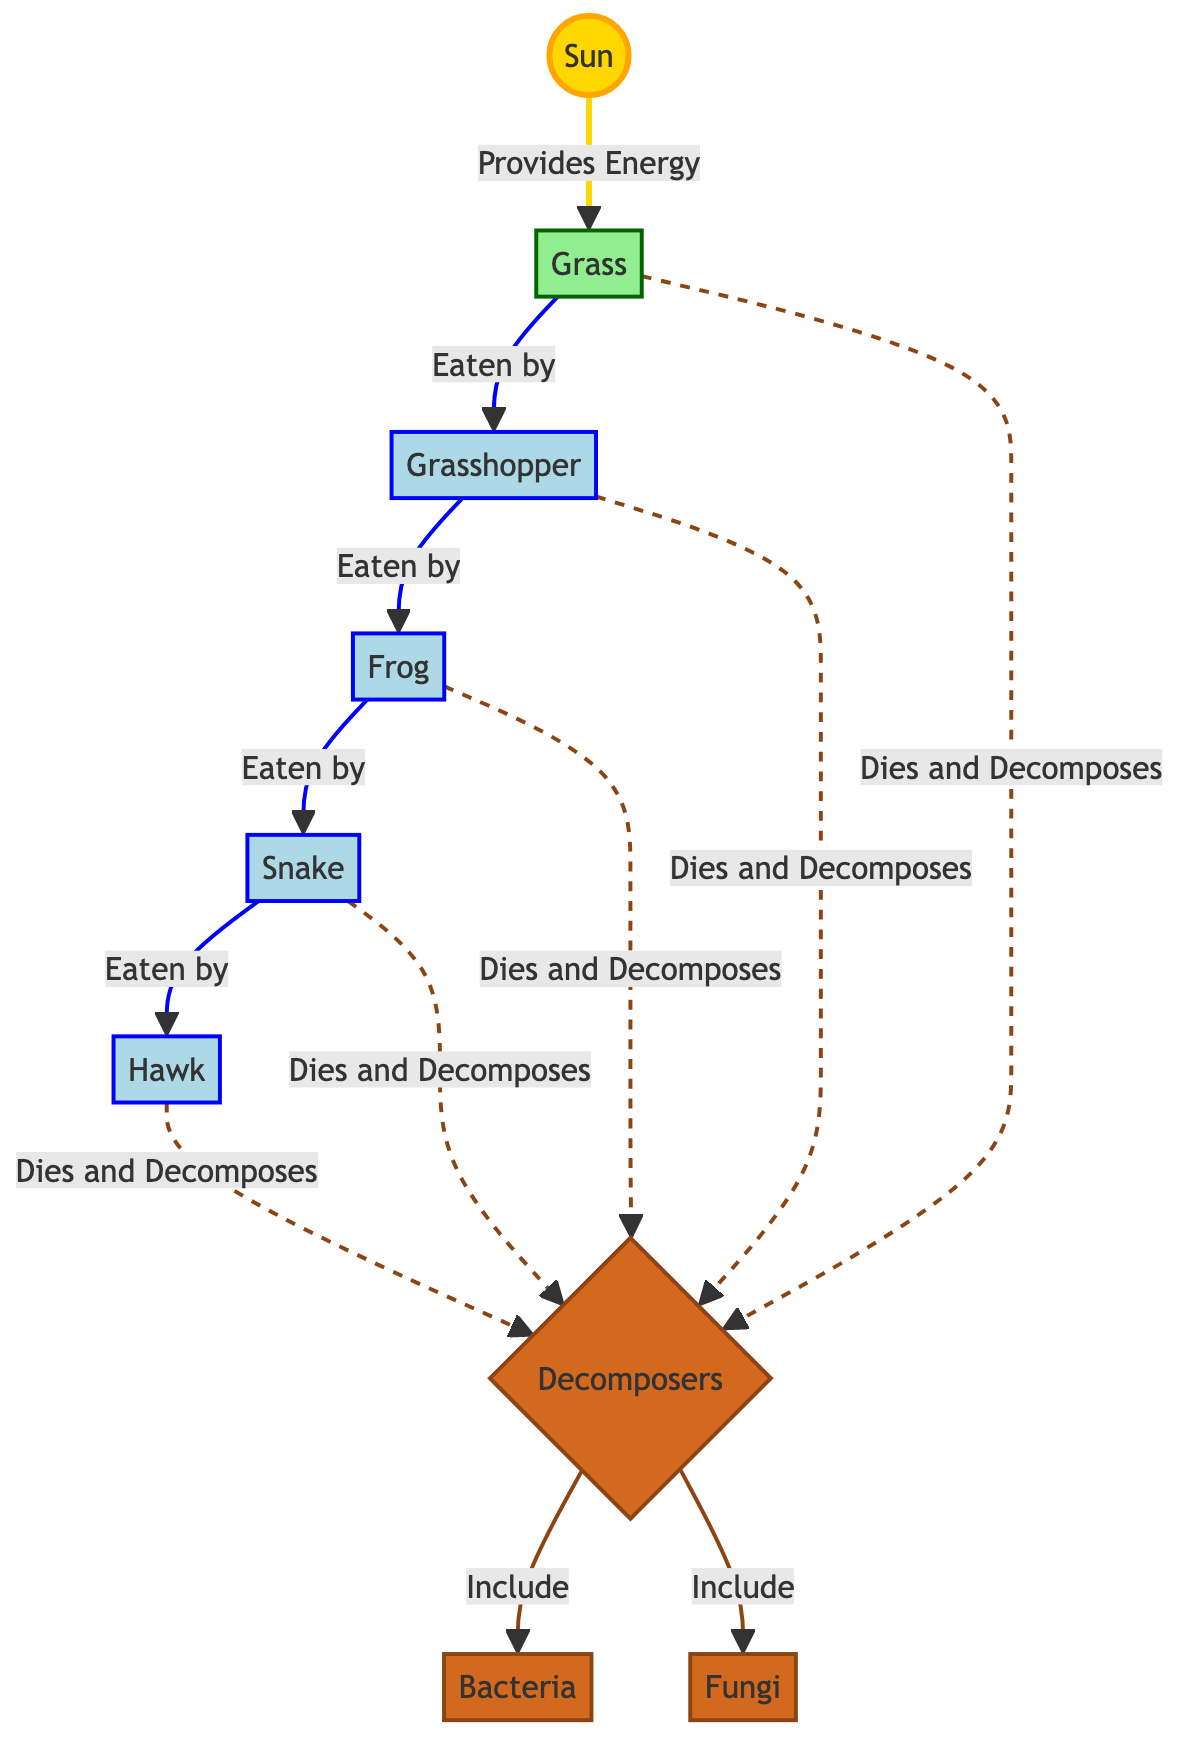What is the primary source of energy in the food chain? The diagram indicates that the Sun is the source of energy, as it points directly to Grass indicating it provides energy to plants.
Answer: Sun How many types of decomposers are shown in the diagram? Looking at the decomposer node, it lists both Bacteria and Fungi, which indicates there are two types included in the diagram.
Answer: 2 Which animal is directly eaten by the Snake? The flow from the Frog shows that it is consumed by the Snake, stating a direct predator-prey relationship in that part of the food chain.
Answer: Frog Who consumes the Grasshopper? The flow from Grasshopper points to the Frog, showing that the Frog is the predator that eats the Grasshopper directly.
Answer: Frog What role do decomposers have in the food chain? The diagram illustrates that decomposers break down organic matter, as indicated by the arrows pointing from the other organisms to the Decomposers node when they die.
Answer: Break down organic matter How does energy flow from the Sun to the Hawk? Energy flows from the Sun to Grass, then to Grasshopper, to Frog, to Snake, and finally to the Hawk, showing a direct chain of energy transfer from one organism to another.
Answer: Through five steps Which animal is at the top of the food chain? The Hawk is shown at the end of the energy flow, indicating it is at the top, as no other predator appears above it in the diagram.
Answer: Hawk What happens to the organisms after they die? The diagram specifies that all organisms (Hawk, Snake, Frog, Grasshopper, and Grass) decompose and are processed by Decomposers, showing their role in recycling nutrients.
Answer: Decomposed by decomposers Which type of link indicates the death of an organism? The dashed line arrow indicates that when an organism dies, it leads to the Decomposers for breaking down organic matter, representing the death event visually.
Answer: Dashed line arrow 